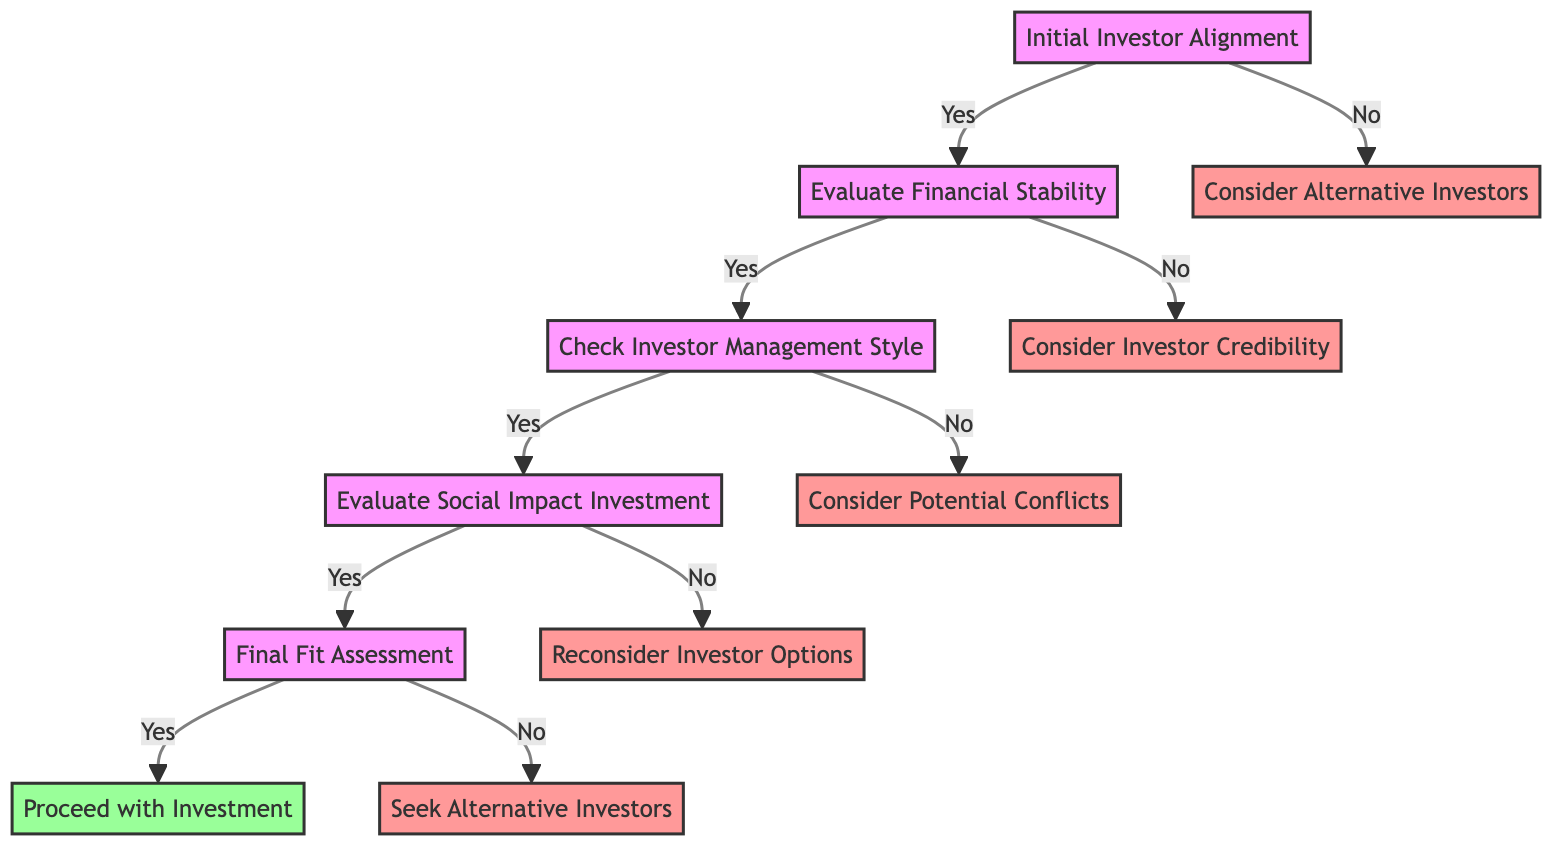What is the first step in the decision tree? The first step in the decision tree is "Initial Investor Alignment." This is the starting point of the flow where the assessment begins.
Answer: Initial Investor Alignment How many nodes are there in total in the diagram? By counting each unique stage and decision point in the flowchart, there are a total of eleven nodes.
Answer: Eleven What happens if the answer to "Does the investor have a history of supporting underrepresented minority founders?" is no? If the answer is no, the next step is to "Consider Alternative Investors," as indicated in the flowchart branching from the initial question.
Answer: Consider Alternative Investors What is evaluated after "Evaluate Financial Stability"? After evaluating financial stability, the next step is to "Check Investor Management Style," as indicated in the decision tree.
Answer: Check Investor Management Style If an investor is deemed to have a poor management style, what should be considered next? If the management style is poor, the following step is to "Consider Potential Conflicts," which is the alternative path indicated in the diagram.
Answer: Consider Potential Conflicts What must be assessed in the "Evaluate Social Impact Investment" step? In this step, key questions revolve around the investor's framework, willingness to balance financial returns, and partnerships with social organizations, to determine their commitment to social impact.
Answer: Investor's commitment to social impact What is the final decision step in the journey through the decision tree? The final step after evaluating all criteria and factors is "Final Fit Assessment," where a comprehensive evaluation is made before making a decision.
Answer: Final Fit Assessment If an investor fails the final fit assessment, what is the next action advised? If the investor does not fit, the next action is to "Seek Alternative Investors," as indicated by the path following the final fit assessment.
Answer: Seek Alternative Investors What criteria leads to the assessment of social impact investment? The assessment of social impact investment follows after "Check Investor Management Style," if the investor's management style is found to be acceptable.
Answer: Check Investor Management Style 